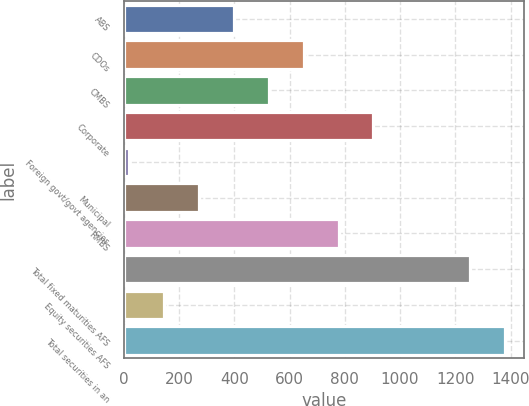Convert chart. <chart><loc_0><loc_0><loc_500><loc_500><bar_chart><fcel>ABS<fcel>CDOs<fcel>CMBS<fcel>Corporate<fcel>Foreign govt/govt agencies<fcel>Municipal<fcel>RMBS<fcel>Total fixed maturities AFS<fcel>Equity securities AFS<fcel>Total securities in an<nl><fcel>398.2<fcel>651<fcel>524.6<fcel>903.8<fcel>19<fcel>271.8<fcel>777.4<fcel>1254<fcel>145.4<fcel>1380.4<nl></chart> 